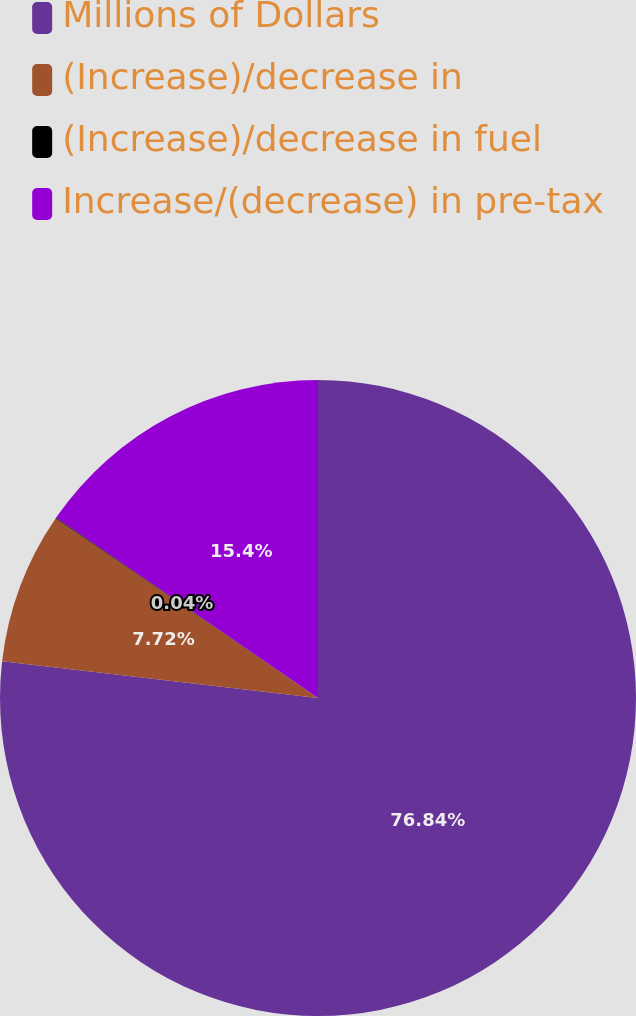Convert chart. <chart><loc_0><loc_0><loc_500><loc_500><pie_chart><fcel>Millions of Dollars<fcel>(Increase)/decrease in<fcel>(Increase)/decrease in fuel<fcel>Increase/(decrease) in pre-tax<nl><fcel>76.84%<fcel>7.72%<fcel>0.04%<fcel>15.4%<nl></chart> 